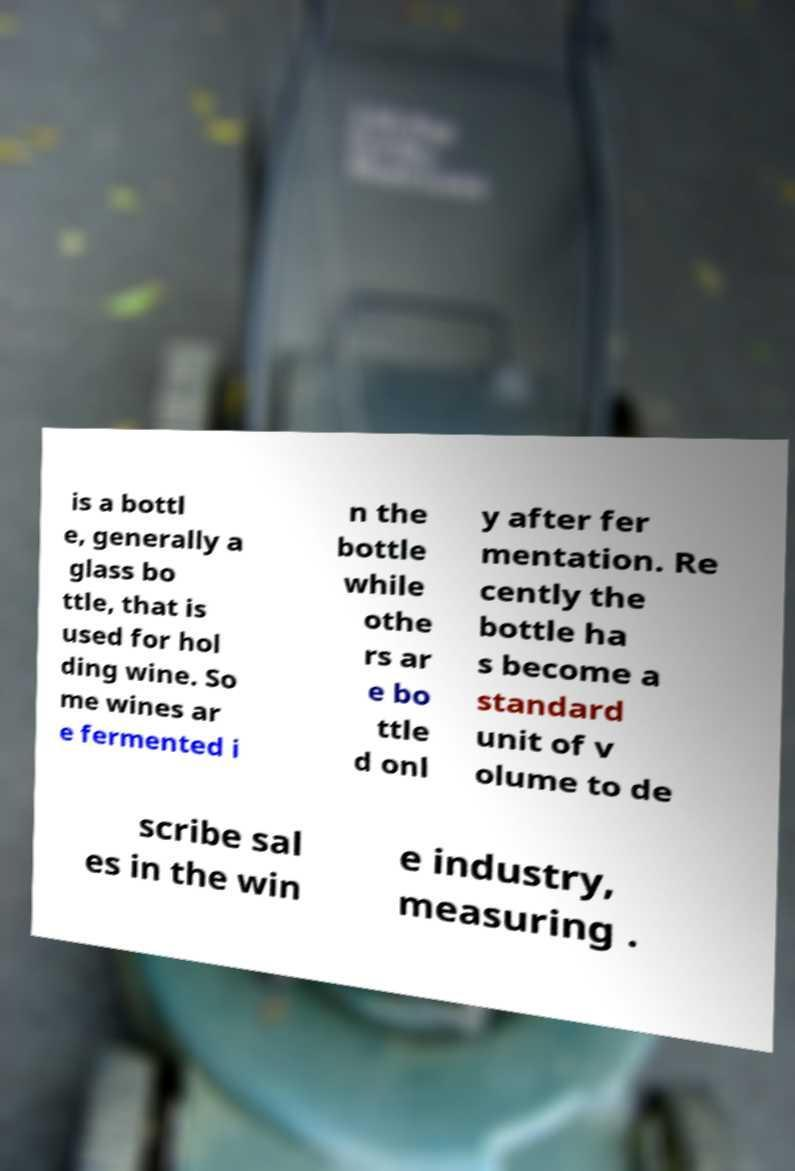For documentation purposes, I need the text within this image transcribed. Could you provide that? is a bottl e, generally a glass bo ttle, that is used for hol ding wine. So me wines ar e fermented i n the bottle while othe rs ar e bo ttle d onl y after fer mentation. Re cently the bottle ha s become a standard unit of v olume to de scribe sal es in the win e industry, measuring . 